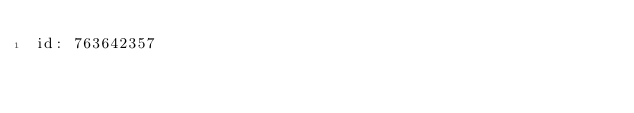Convert code to text. <code><loc_0><loc_0><loc_500><loc_500><_YAML_>id: 763642357
</code> 